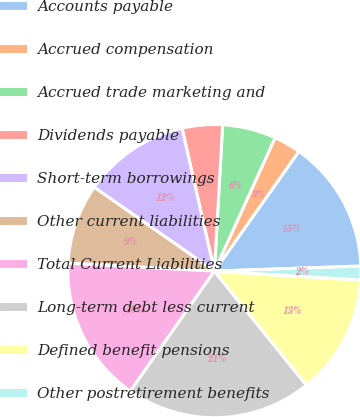Convert chart to OTSL. <chart><loc_0><loc_0><loc_500><loc_500><pie_chart><fcel>Accounts payable<fcel>Accrued compensation<fcel>Accrued trade marketing and<fcel>Dividends payable<fcel>Short-term borrowings<fcel>Other current liabilities<fcel>Total Current Liabilities<fcel>Long-term debt less current<fcel>Defined benefit pensions<fcel>Other postretirement benefits<nl><fcel>14.68%<fcel>2.98%<fcel>5.9%<fcel>4.44%<fcel>11.76%<fcel>8.83%<fcel>16.14%<fcel>20.53%<fcel>13.22%<fcel>1.52%<nl></chart> 